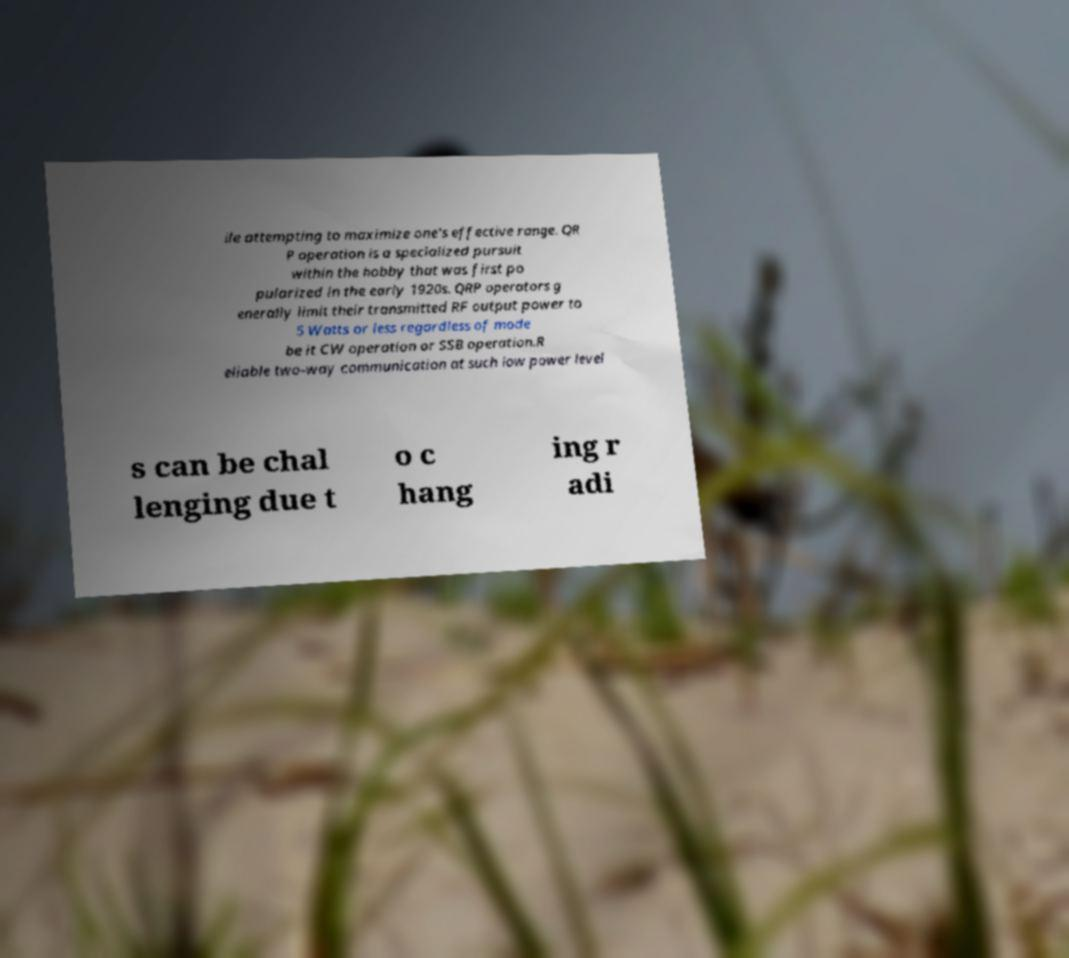Please read and relay the text visible in this image. What does it say? ile attempting to maximize one's effective range. QR P operation is a specialized pursuit within the hobby that was first po pularized in the early 1920s. QRP operators g enerally limit their transmitted RF output power to 5 Watts or less regardless of mode be it CW operation or SSB operation.R eliable two-way communication at such low power level s can be chal lenging due t o c hang ing r adi 